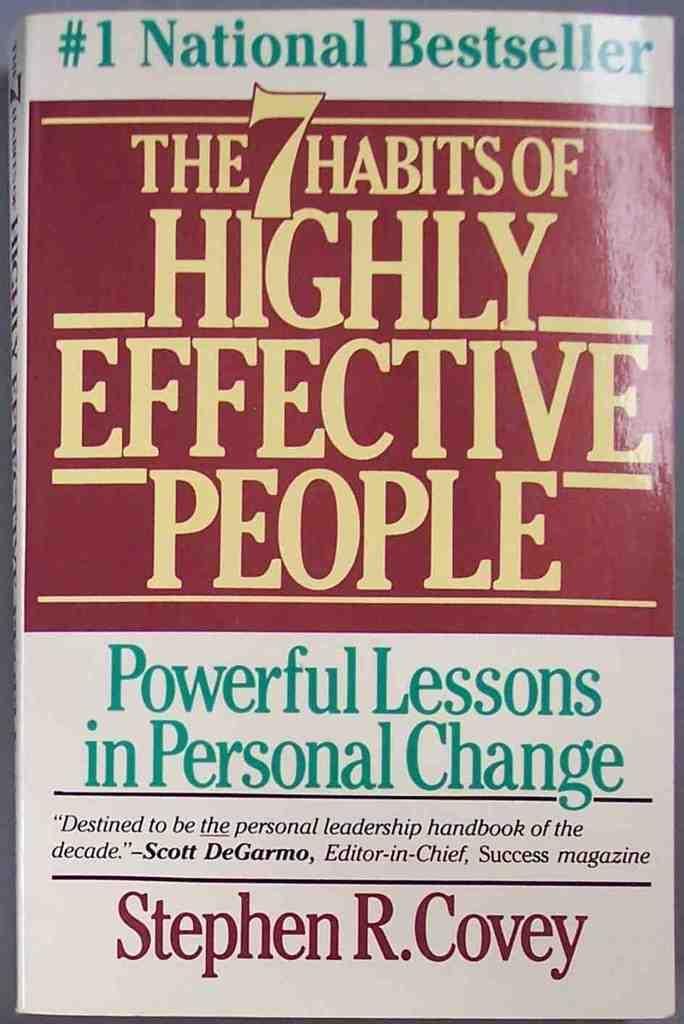<image>
Provide a brief description of the given image. A book titled The 7 habits of highly effective people 